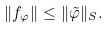Convert formula to latex. <formula><loc_0><loc_0><loc_500><loc_500>\| f _ { \varphi } \| \leq \| \tilde { \varphi } \| _ { S } .</formula> 